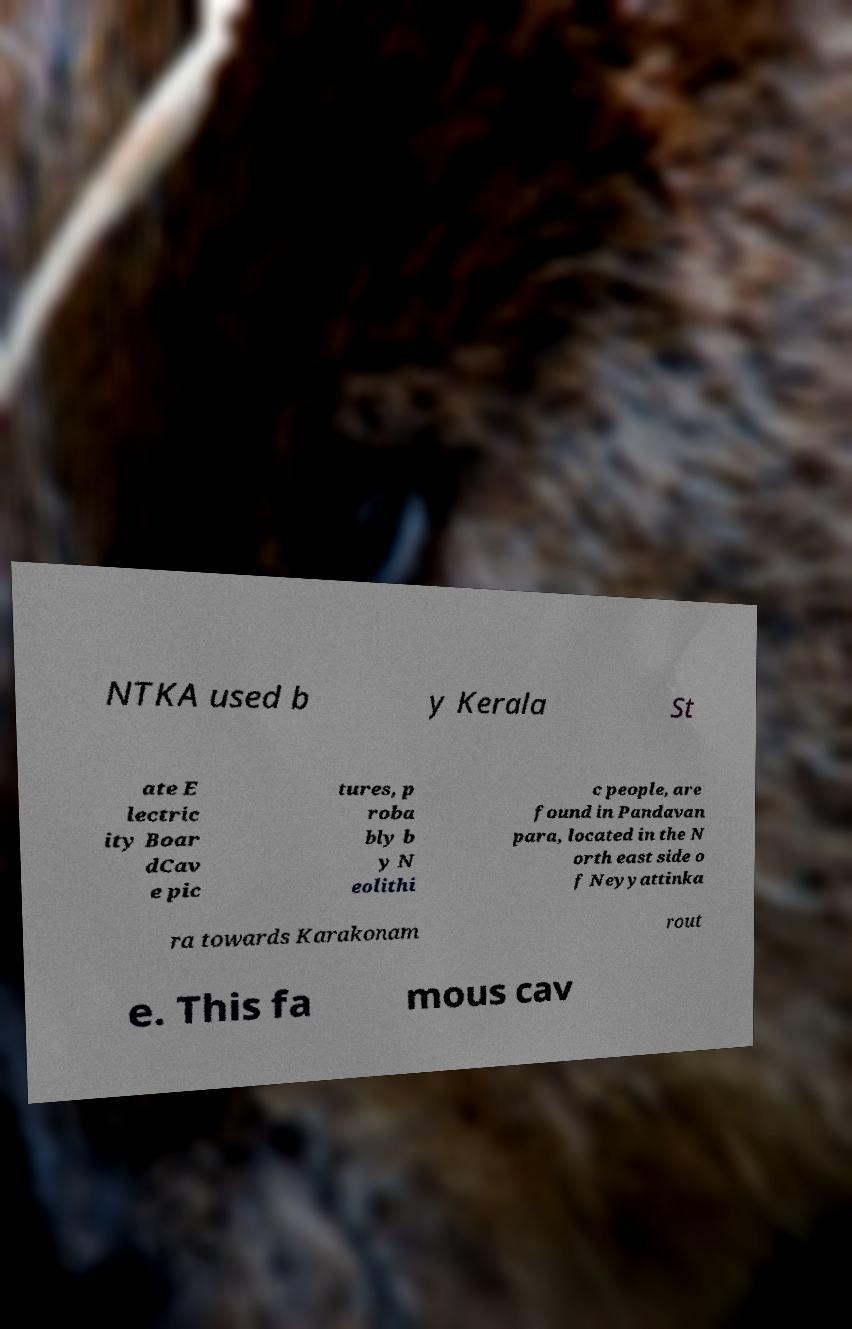What messages or text are displayed in this image? I need them in a readable, typed format. NTKA used b y Kerala St ate E lectric ity Boar dCav e pic tures, p roba bly b y N eolithi c people, are found in Pandavan para, located in the N orth east side o f Neyyattinka ra towards Karakonam rout e. This fa mous cav 